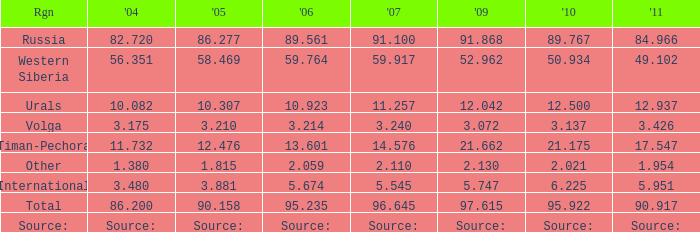What is the 2007 Lukoil oil prodroduction when in 2010 oil production 3.137 million tonnes? 3.24. 